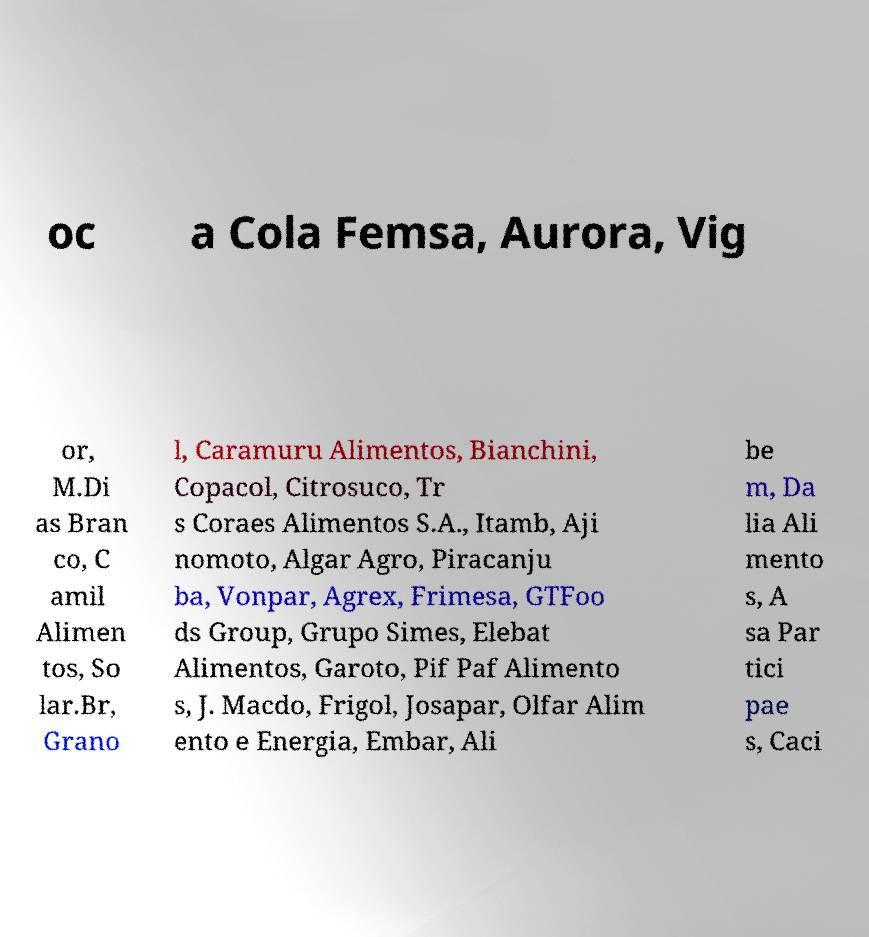Could you assist in decoding the text presented in this image and type it out clearly? oc a Cola Femsa, Aurora, Vig or, M.Di as Bran co, C amil Alimen tos, So lar.Br, Grano l, Caramuru Alimentos, Bianchini, Copacol, Citrosuco, Tr s Coraes Alimentos S.A., Itamb, Aji nomoto, Algar Agro, Piracanju ba, Vonpar, Agrex, Frimesa, GTFoo ds Group, Grupo Simes, Elebat Alimentos, Garoto, Pif Paf Alimento s, J. Macdo, Frigol, Josapar, Olfar Alim ento e Energia, Embar, Ali be m, Da lia Ali mento s, A sa Par tici pae s, Caci 